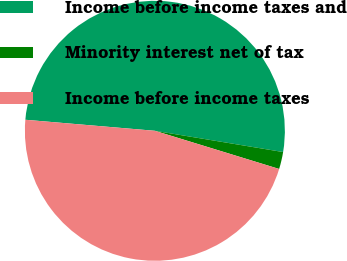Convert chart. <chart><loc_0><loc_0><loc_500><loc_500><pie_chart><fcel>Income before income taxes and<fcel>Minority interest net of tax<fcel>Income before income taxes<nl><fcel>51.26%<fcel>2.13%<fcel>46.61%<nl></chart> 